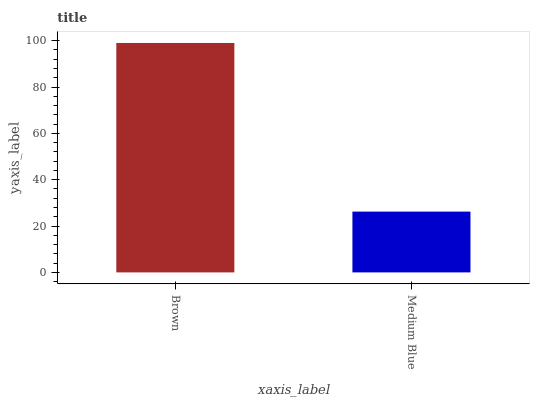Is Medium Blue the minimum?
Answer yes or no. Yes. Is Brown the maximum?
Answer yes or no. Yes. Is Medium Blue the maximum?
Answer yes or no. No. Is Brown greater than Medium Blue?
Answer yes or no. Yes. Is Medium Blue less than Brown?
Answer yes or no. Yes. Is Medium Blue greater than Brown?
Answer yes or no. No. Is Brown less than Medium Blue?
Answer yes or no. No. Is Brown the high median?
Answer yes or no. Yes. Is Medium Blue the low median?
Answer yes or no. Yes. Is Medium Blue the high median?
Answer yes or no. No. Is Brown the low median?
Answer yes or no. No. 